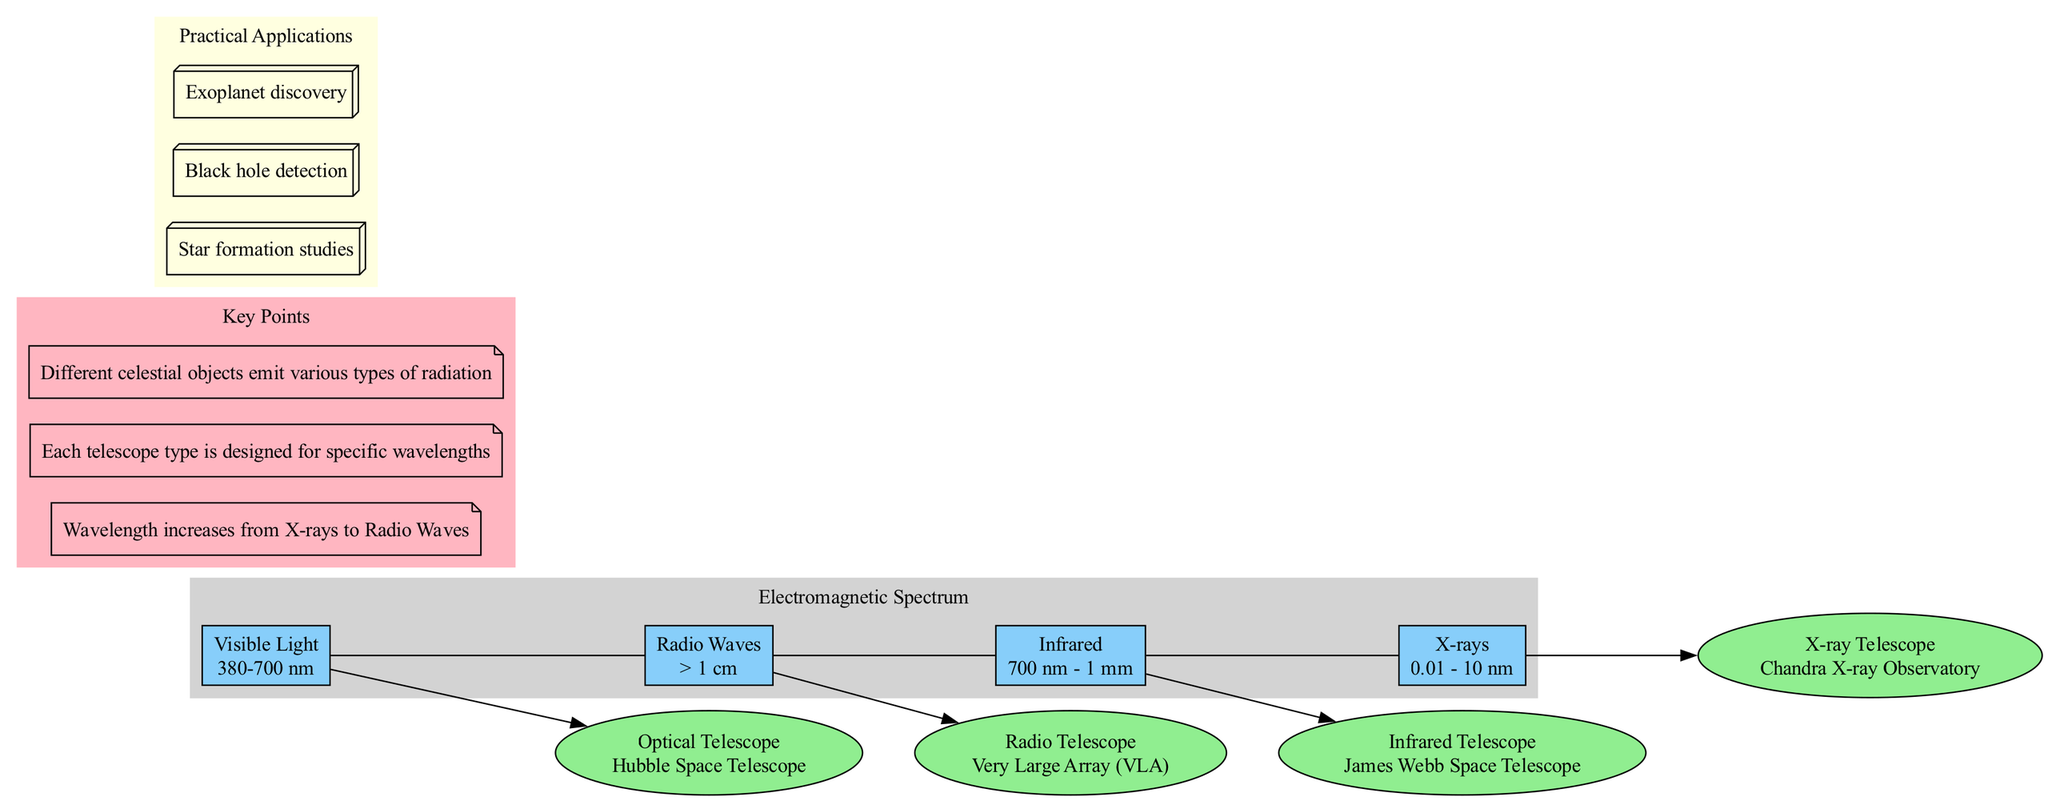What is the wavelength range for visible light? The diagram specifies that the wavelength range for visible light is between 380 to 700 nanometers. This information can be found under the "Visible Light" section of the diagram.
Answer: 380-700 nm Which telescope is used to observe infrared wavelengths? In the "Infrared" section of the diagram, it identifies that the James Webb Space Telescope is the example of an infrared telescope used for observing this range.
Answer: James Webb Space Telescope What is the relationship between X-rays and radio waves in terms of wavelength? The diagram indicates that the wavelength increases from X-rays to Radio Waves. This relationship implies that X-rays have shorter wavelengths compared to radio waves.
Answer: Increases How many different types of telescopes are presented in the diagram? By counting the nodes in the diagram, there are four types of telescopes associated with different sections of the electromagnetic spectrum: Optical, Radio, Infrared, and X-ray telescopes.
Answer: Four What scientific application is associated with black hole detection? The practical applications section of the diagram specifies "Black hole detection" as one of the applications of observing different types of radiation in astronomy.
Answer: Black hole detection Which section of the diagram has the longest wavelength? The diagram shows that the Radio Waves section has the longest wavelength, as indicated by the wavelength specification of greater than one centimeter in the main sections.
Answer: Radio Waves What type of radiation is associated with the Hubble Space Telescope? The Hubble Space Telescope, noted in the "Visible Light" section, is associated with visible light radiation, as it is designed to observe that specific part of the electromagnetic spectrum.
Answer: Visible Light What color represents the key points in the diagram? The key points are displayed in a light pink filled background according to the section's attributes identified in the diagram.
Answer: Light pink Which telescope would be used for observing wavelengths less than 10 nanometers? The diagram identifies the Chandra X-ray Observatory as the telescope designed for observing X-rays, which are in the range of 0.01 to 10 nanometers.
Answer: Chandra X-ray Observatory 